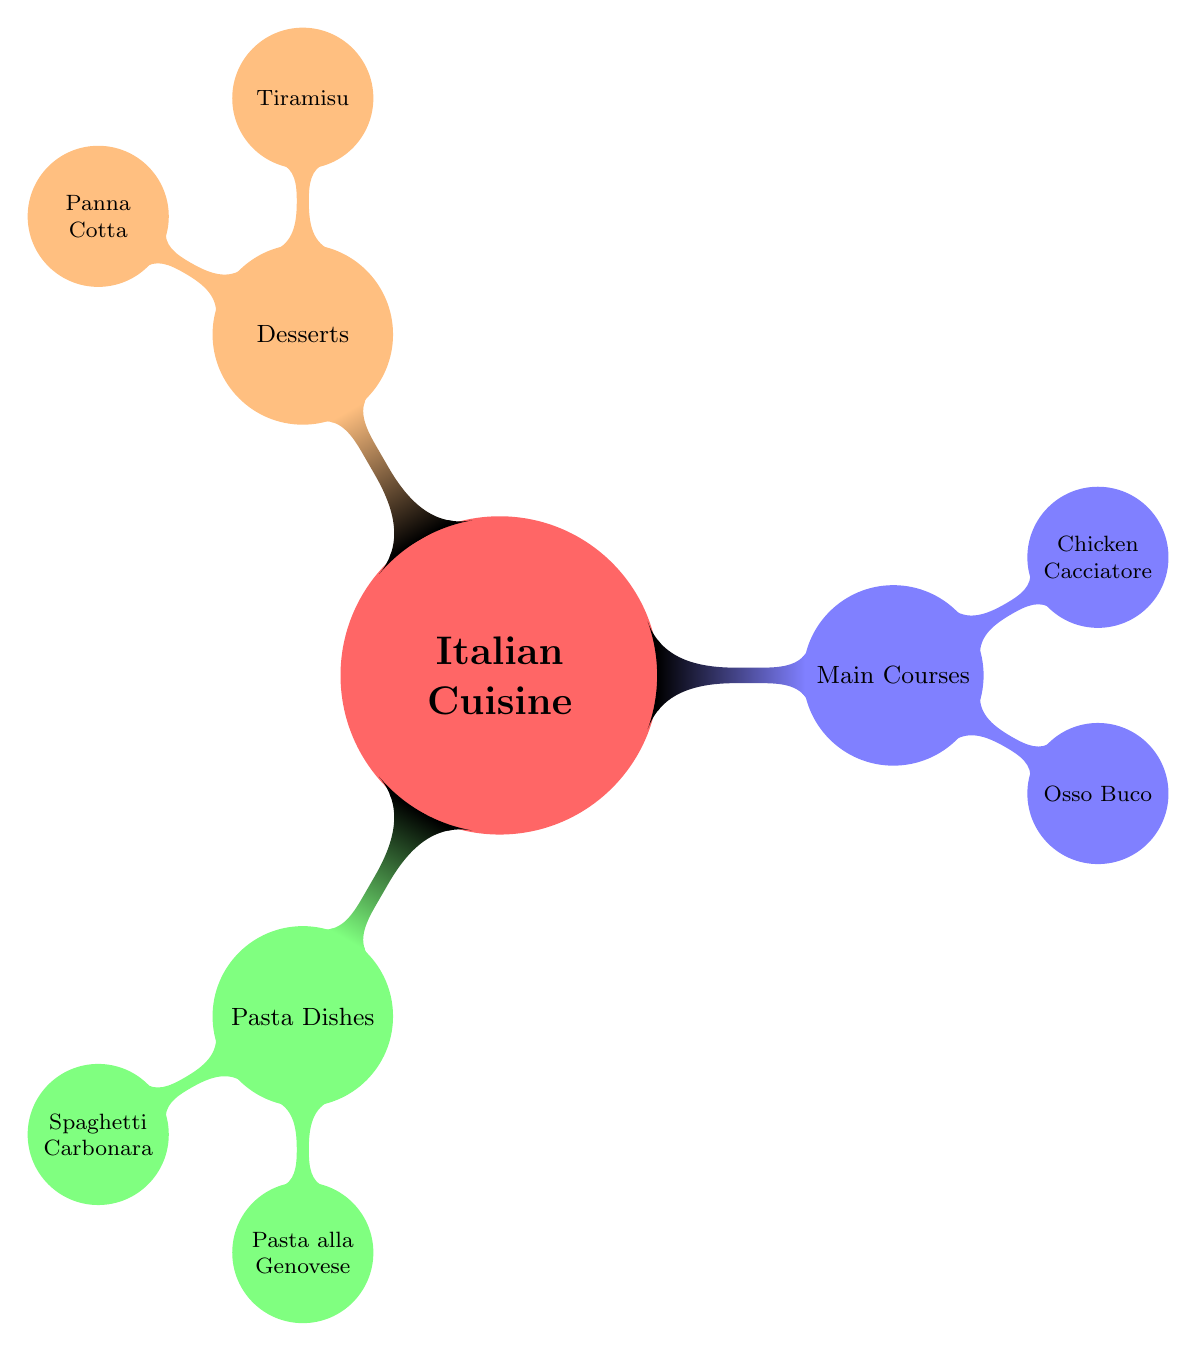What are the three main categories in Italian Cuisine? The mind map shows three primary child nodes branching from the main node "Italian Cuisine": Pasta Dishes, Main Courses, and Desserts.
Answer: Pasta Dishes, Main Courses, Desserts How many pasta dishes are listed in the diagram? The node "Pasta Dishes" has two children: Spaghetti Carbonara and Pasta alla Genovese, indicating that there are two pasta dishes in total.
Answer: 2 What is the main ingredient in Spaghetti Carbonara? Within the Spaghetti Carbonara node, it states "Spaghetti" as the first ingredient listed, indicating it is the main ingredient.
Answer: Spaghetti Which dessert requires refrigeration overnight? The Tiramisu node specifically mentions the cooking tip "Refrigerate overnight," which indicates that this dessert needs to be refrigerated for that time period.
Answer: Tiramisu What technique can enhance the flavor of Chicken Cacciatore? The Cooking Tips for Chicken Cacciatore mentions "Add olives for extra flavor," implying that incorporating olives is recommended for enhancing its taste.
Answer: Add olives Which dish requires marinating overnight according to the cooking tips? The node for Osso Buco states "Marinate veal shanks overnight" under its cooking tips, indicating this is a requirement for that dish.
Answer: Osso Buco What ingredient is suggested for Pasta alla Genovese to avoid overcooking? The Pasta alla Genovese cooking tip states "Do not overcook green beans," meaning that this ingredient needs proper cooking attention.
Answer: Green Beans How is the cream for Panna Cotta meant to be heated? The cooking tip for Panna Cotta instructs to "Heat cream but do not boil," indicating the specific method of heating required.
Answer: Heat but do not boil 